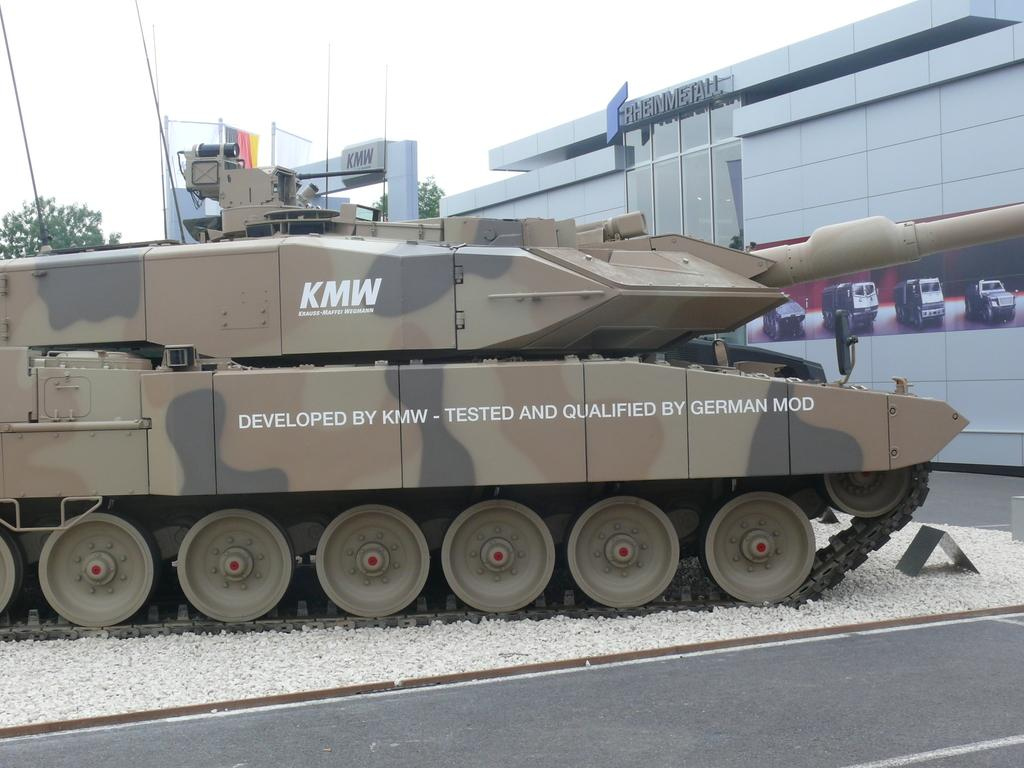What is the main subject of the image? The main subject of the image is an army tank. Can you describe the setting of the image? There is a building behind the tank in the image. How many ants can be seen carrying corn on their voyage in the image? There are no ants, corn, or voyages depicted in the image; it features an army tank and a building. 